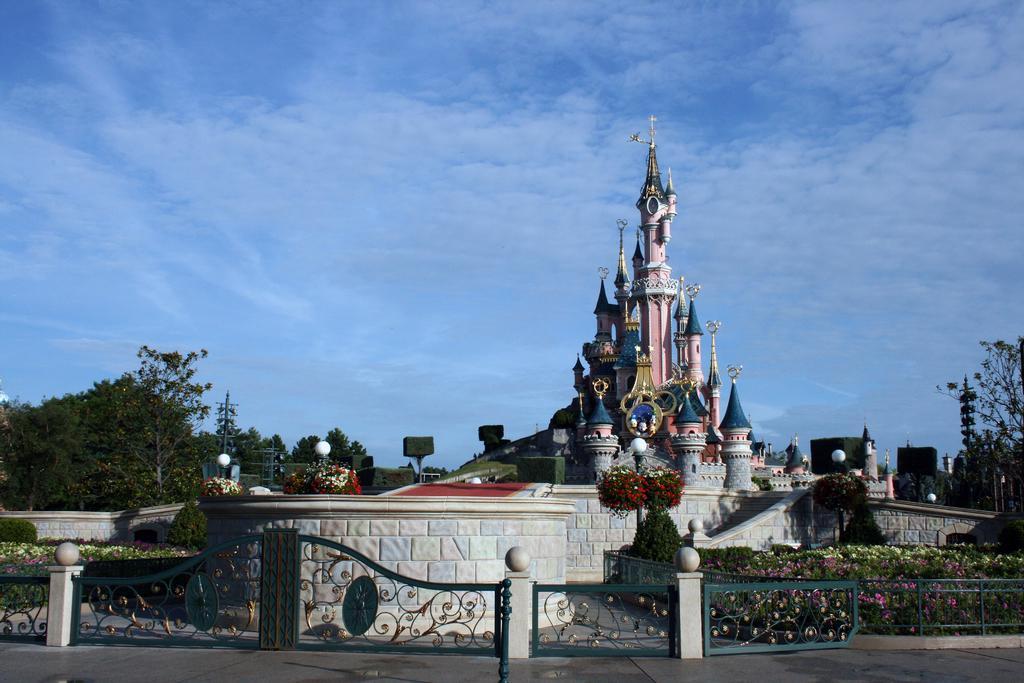Could you give a brief overview of what you see in this image? In the picture we can see the railing wall and behind it, we can see the Disney land, building and beside it, we can see many trees and in the background we can see the sky with clouds. 